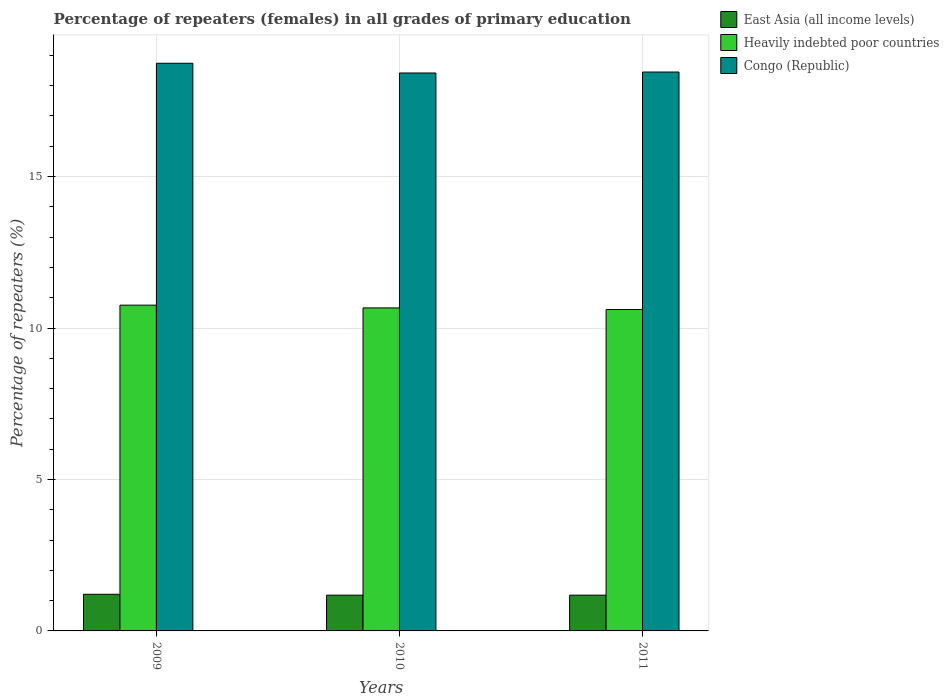Are the number of bars per tick equal to the number of legend labels?
Make the answer very short. Yes. How many bars are there on the 3rd tick from the left?
Offer a very short reply. 3. How many bars are there on the 1st tick from the right?
Offer a very short reply. 3. What is the percentage of repeaters (females) in Heavily indebted poor countries in 2011?
Provide a succinct answer. 10.61. Across all years, what is the maximum percentage of repeaters (females) in East Asia (all income levels)?
Give a very brief answer. 1.21. Across all years, what is the minimum percentage of repeaters (females) in Congo (Republic)?
Offer a terse response. 18.42. What is the total percentage of repeaters (females) in Heavily indebted poor countries in the graph?
Give a very brief answer. 32.03. What is the difference between the percentage of repeaters (females) in East Asia (all income levels) in 2010 and that in 2011?
Offer a very short reply. -0. What is the difference between the percentage of repeaters (females) in East Asia (all income levels) in 2010 and the percentage of repeaters (females) in Congo (Republic) in 2009?
Keep it short and to the point. -17.56. What is the average percentage of repeaters (females) in Congo (Republic) per year?
Make the answer very short. 18.54. In the year 2009, what is the difference between the percentage of repeaters (females) in Congo (Republic) and percentage of repeaters (females) in East Asia (all income levels)?
Your answer should be compact. 17.53. What is the ratio of the percentage of repeaters (females) in Heavily indebted poor countries in 2009 to that in 2010?
Your answer should be very brief. 1.01. What is the difference between the highest and the second highest percentage of repeaters (females) in Heavily indebted poor countries?
Your answer should be very brief. 0.09. What is the difference between the highest and the lowest percentage of repeaters (females) in Heavily indebted poor countries?
Your answer should be compact. 0.14. Is the sum of the percentage of repeaters (females) in Heavily indebted poor countries in 2009 and 2010 greater than the maximum percentage of repeaters (females) in Congo (Republic) across all years?
Provide a succinct answer. Yes. What does the 1st bar from the left in 2011 represents?
Offer a very short reply. East Asia (all income levels). What does the 2nd bar from the right in 2010 represents?
Provide a short and direct response. Heavily indebted poor countries. Are all the bars in the graph horizontal?
Ensure brevity in your answer.  No. Are the values on the major ticks of Y-axis written in scientific E-notation?
Make the answer very short. No. Does the graph contain any zero values?
Make the answer very short. No. Where does the legend appear in the graph?
Offer a very short reply. Top right. How many legend labels are there?
Offer a very short reply. 3. How are the legend labels stacked?
Your answer should be very brief. Vertical. What is the title of the graph?
Offer a terse response. Percentage of repeaters (females) in all grades of primary education. Does "Malta" appear as one of the legend labels in the graph?
Provide a short and direct response. No. What is the label or title of the Y-axis?
Your response must be concise. Percentage of repeaters (%). What is the Percentage of repeaters (%) in East Asia (all income levels) in 2009?
Keep it short and to the point. 1.21. What is the Percentage of repeaters (%) in Heavily indebted poor countries in 2009?
Make the answer very short. 10.76. What is the Percentage of repeaters (%) of Congo (Republic) in 2009?
Your answer should be very brief. 18.74. What is the Percentage of repeaters (%) in East Asia (all income levels) in 2010?
Keep it short and to the point. 1.18. What is the Percentage of repeaters (%) in Heavily indebted poor countries in 2010?
Your response must be concise. 10.66. What is the Percentage of repeaters (%) of Congo (Republic) in 2010?
Your answer should be compact. 18.42. What is the Percentage of repeaters (%) of East Asia (all income levels) in 2011?
Provide a succinct answer. 1.18. What is the Percentage of repeaters (%) in Heavily indebted poor countries in 2011?
Your answer should be compact. 10.61. What is the Percentage of repeaters (%) of Congo (Republic) in 2011?
Your answer should be very brief. 18.45. Across all years, what is the maximum Percentage of repeaters (%) in East Asia (all income levels)?
Give a very brief answer. 1.21. Across all years, what is the maximum Percentage of repeaters (%) of Heavily indebted poor countries?
Ensure brevity in your answer.  10.76. Across all years, what is the maximum Percentage of repeaters (%) in Congo (Republic)?
Give a very brief answer. 18.74. Across all years, what is the minimum Percentage of repeaters (%) in East Asia (all income levels)?
Provide a succinct answer. 1.18. Across all years, what is the minimum Percentage of repeaters (%) in Heavily indebted poor countries?
Keep it short and to the point. 10.61. Across all years, what is the minimum Percentage of repeaters (%) in Congo (Republic)?
Your answer should be very brief. 18.42. What is the total Percentage of repeaters (%) in East Asia (all income levels) in the graph?
Make the answer very short. 3.57. What is the total Percentage of repeaters (%) of Heavily indebted poor countries in the graph?
Keep it short and to the point. 32.03. What is the total Percentage of repeaters (%) in Congo (Republic) in the graph?
Ensure brevity in your answer.  55.61. What is the difference between the Percentage of repeaters (%) of East Asia (all income levels) in 2009 and that in 2010?
Offer a very short reply. 0.03. What is the difference between the Percentage of repeaters (%) of Heavily indebted poor countries in 2009 and that in 2010?
Keep it short and to the point. 0.09. What is the difference between the Percentage of repeaters (%) in Congo (Republic) in 2009 and that in 2010?
Offer a very short reply. 0.32. What is the difference between the Percentage of repeaters (%) of East Asia (all income levels) in 2009 and that in 2011?
Offer a very short reply. 0.03. What is the difference between the Percentage of repeaters (%) of Heavily indebted poor countries in 2009 and that in 2011?
Give a very brief answer. 0.14. What is the difference between the Percentage of repeaters (%) in Congo (Republic) in 2009 and that in 2011?
Your response must be concise. 0.29. What is the difference between the Percentage of repeaters (%) in East Asia (all income levels) in 2010 and that in 2011?
Provide a short and direct response. -0. What is the difference between the Percentage of repeaters (%) of Heavily indebted poor countries in 2010 and that in 2011?
Keep it short and to the point. 0.05. What is the difference between the Percentage of repeaters (%) of Congo (Republic) in 2010 and that in 2011?
Offer a terse response. -0.03. What is the difference between the Percentage of repeaters (%) of East Asia (all income levels) in 2009 and the Percentage of repeaters (%) of Heavily indebted poor countries in 2010?
Your answer should be very brief. -9.45. What is the difference between the Percentage of repeaters (%) of East Asia (all income levels) in 2009 and the Percentage of repeaters (%) of Congo (Republic) in 2010?
Your answer should be very brief. -17.21. What is the difference between the Percentage of repeaters (%) of Heavily indebted poor countries in 2009 and the Percentage of repeaters (%) of Congo (Republic) in 2010?
Offer a terse response. -7.66. What is the difference between the Percentage of repeaters (%) in East Asia (all income levels) in 2009 and the Percentage of repeaters (%) in Heavily indebted poor countries in 2011?
Offer a very short reply. -9.4. What is the difference between the Percentage of repeaters (%) of East Asia (all income levels) in 2009 and the Percentage of repeaters (%) of Congo (Republic) in 2011?
Offer a terse response. -17.24. What is the difference between the Percentage of repeaters (%) of Heavily indebted poor countries in 2009 and the Percentage of repeaters (%) of Congo (Republic) in 2011?
Offer a terse response. -7.7. What is the difference between the Percentage of repeaters (%) of East Asia (all income levels) in 2010 and the Percentage of repeaters (%) of Heavily indebted poor countries in 2011?
Keep it short and to the point. -9.43. What is the difference between the Percentage of repeaters (%) of East Asia (all income levels) in 2010 and the Percentage of repeaters (%) of Congo (Republic) in 2011?
Make the answer very short. -17.27. What is the difference between the Percentage of repeaters (%) of Heavily indebted poor countries in 2010 and the Percentage of repeaters (%) of Congo (Republic) in 2011?
Provide a succinct answer. -7.79. What is the average Percentage of repeaters (%) of East Asia (all income levels) per year?
Your response must be concise. 1.19. What is the average Percentage of repeaters (%) of Heavily indebted poor countries per year?
Offer a very short reply. 10.68. What is the average Percentage of repeaters (%) of Congo (Republic) per year?
Offer a very short reply. 18.54. In the year 2009, what is the difference between the Percentage of repeaters (%) in East Asia (all income levels) and Percentage of repeaters (%) in Heavily indebted poor countries?
Provide a succinct answer. -9.55. In the year 2009, what is the difference between the Percentage of repeaters (%) of East Asia (all income levels) and Percentage of repeaters (%) of Congo (Republic)?
Provide a short and direct response. -17.53. In the year 2009, what is the difference between the Percentage of repeaters (%) in Heavily indebted poor countries and Percentage of repeaters (%) in Congo (Republic)?
Ensure brevity in your answer.  -7.99. In the year 2010, what is the difference between the Percentage of repeaters (%) of East Asia (all income levels) and Percentage of repeaters (%) of Heavily indebted poor countries?
Offer a terse response. -9.48. In the year 2010, what is the difference between the Percentage of repeaters (%) in East Asia (all income levels) and Percentage of repeaters (%) in Congo (Republic)?
Your response must be concise. -17.24. In the year 2010, what is the difference between the Percentage of repeaters (%) in Heavily indebted poor countries and Percentage of repeaters (%) in Congo (Republic)?
Make the answer very short. -7.76. In the year 2011, what is the difference between the Percentage of repeaters (%) in East Asia (all income levels) and Percentage of repeaters (%) in Heavily indebted poor countries?
Ensure brevity in your answer.  -9.43. In the year 2011, what is the difference between the Percentage of repeaters (%) of East Asia (all income levels) and Percentage of repeaters (%) of Congo (Republic)?
Offer a very short reply. -17.27. In the year 2011, what is the difference between the Percentage of repeaters (%) of Heavily indebted poor countries and Percentage of repeaters (%) of Congo (Republic)?
Your answer should be very brief. -7.84. What is the ratio of the Percentage of repeaters (%) in East Asia (all income levels) in 2009 to that in 2010?
Offer a very short reply. 1.02. What is the ratio of the Percentage of repeaters (%) in Heavily indebted poor countries in 2009 to that in 2010?
Give a very brief answer. 1.01. What is the ratio of the Percentage of repeaters (%) of Congo (Republic) in 2009 to that in 2010?
Provide a short and direct response. 1.02. What is the ratio of the Percentage of repeaters (%) in East Asia (all income levels) in 2009 to that in 2011?
Give a very brief answer. 1.02. What is the ratio of the Percentage of repeaters (%) in Heavily indebted poor countries in 2009 to that in 2011?
Ensure brevity in your answer.  1.01. What is the ratio of the Percentage of repeaters (%) of Congo (Republic) in 2009 to that in 2011?
Your response must be concise. 1.02. What is the ratio of the Percentage of repeaters (%) of East Asia (all income levels) in 2010 to that in 2011?
Provide a short and direct response. 1. What is the ratio of the Percentage of repeaters (%) in Heavily indebted poor countries in 2010 to that in 2011?
Provide a short and direct response. 1. What is the difference between the highest and the second highest Percentage of repeaters (%) in East Asia (all income levels)?
Keep it short and to the point. 0.03. What is the difference between the highest and the second highest Percentage of repeaters (%) of Heavily indebted poor countries?
Ensure brevity in your answer.  0.09. What is the difference between the highest and the second highest Percentage of repeaters (%) in Congo (Republic)?
Keep it short and to the point. 0.29. What is the difference between the highest and the lowest Percentage of repeaters (%) in East Asia (all income levels)?
Provide a succinct answer. 0.03. What is the difference between the highest and the lowest Percentage of repeaters (%) of Heavily indebted poor countries?
Your answer should be compact. 0.14. What is the difference between the highest and the lowest Percentage of repeaters (%) of Congo (Republic)?
Your answer should be compact. 0.32. 